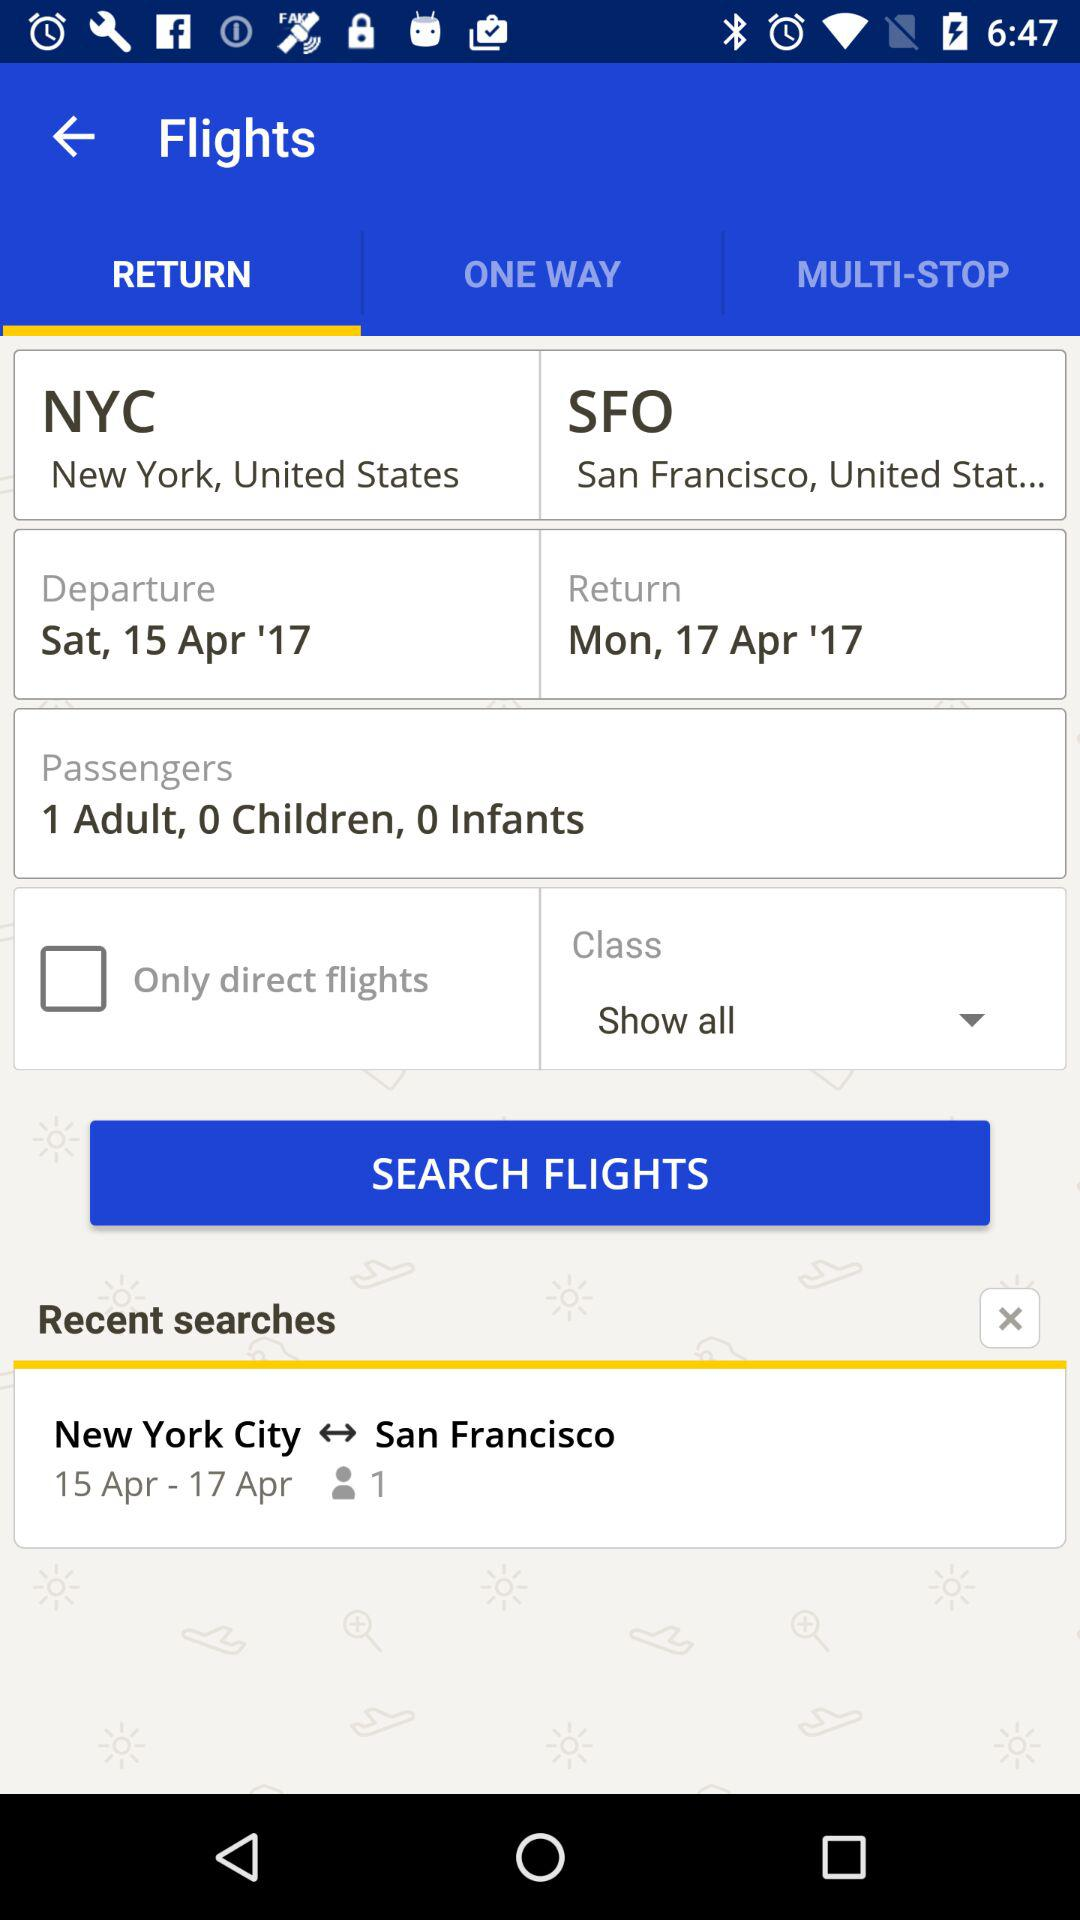What is the destination location? The destination location is "San Francisco, United Stat...". 